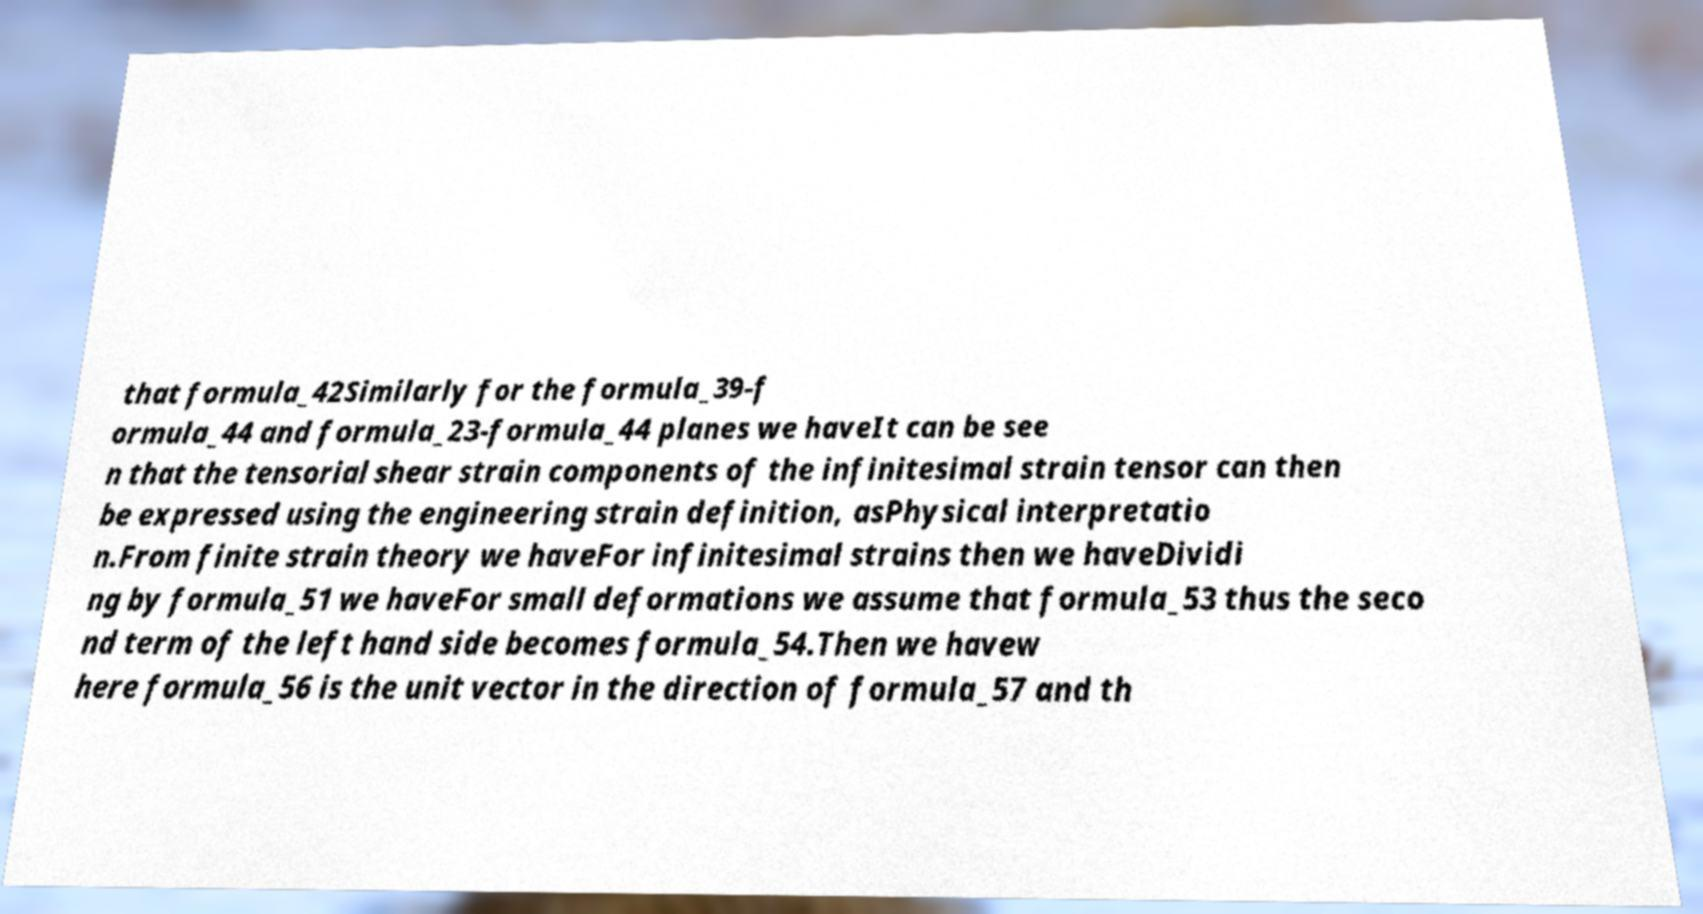For documentation purposes, I need the text within this image transcribed. Could you provide that? that formula_42Similarly for the formula_39-f ormula_44 and formula_23-formula_44 planes we haveIt can be see n that the tensorial shear strain components of the infinitesimal strain tensor can then be expressed using the engineering strain definition, asPhysical interpretatio n.From finite strain theory we haveFor infinitesimal strains then we haveDividi ng by formula_51 we haveFor small deformations we assume that formula_53 thus the seco nd term of the left hand side becomes formula_54.Then we havew here formula_56 is the unit vector in the direction of formula_57 and th 